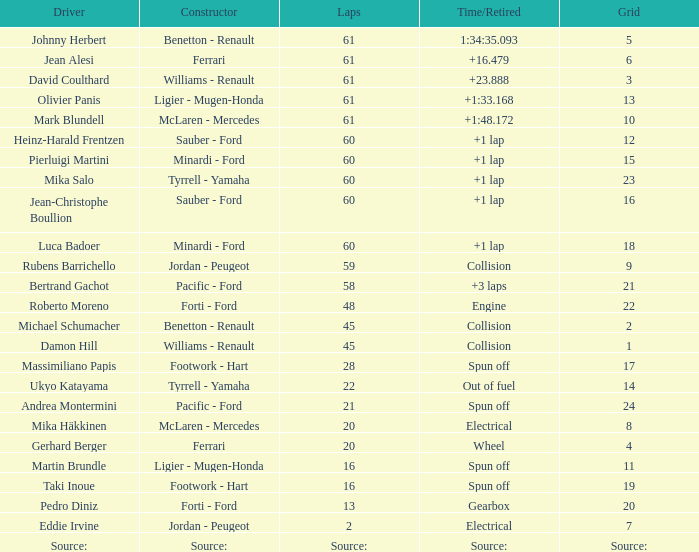How many laps does luca badoer have? 60.0. 